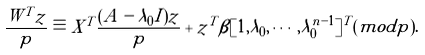Convert formula to latex. <formula><loc_0><loc_0><loc_500><loc_500>\frac { W ^ { T } z } { p } \equiv X ^ { T } \frac { ( A - \lambda _ { 0 } I ) z } { p } + z ^ { T } \beta [ 1 , \lambda _ { 0 } , \cdots , \lambda _ { 0 } ^ { n - 1 } ] ^ { T } ( m o d p ) .</formula> 